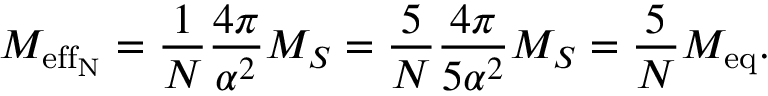<formula> <loc_0><loc_0><loc_500><loc_500>M _ { e f f _ { N } } = \frac { 1 } { N } \frac { 4 \pi } { \alpha ^ { 2 } } M _ { S } = \frac { 5 } { N } \frac { 4 \pi } { 5 \alpha ^ { 2 } } M _ { S } = \frac { 5 } { N } M _ { e q } .</formula> 